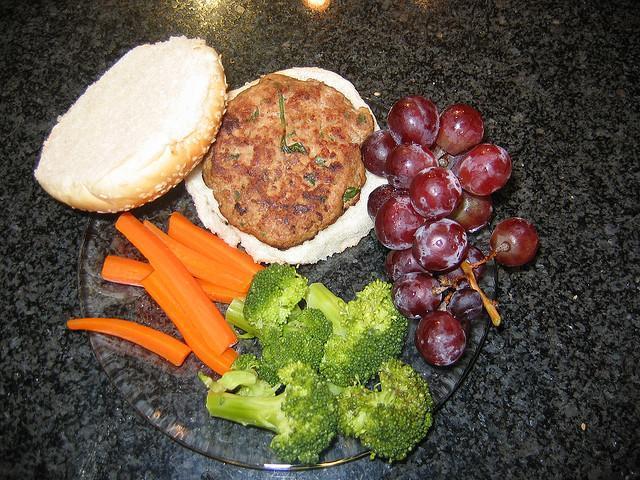How many different food groups are represented?
Give a very brief answer. 3. How many of these foods come from grain?
Give a very brief answer. 1. How many broccolis are there?
Give a very brief answer. 2. How many carrots are there?
Give a very brief answer. 4. How many kites in sky?
Give a very brief answer. 0. 